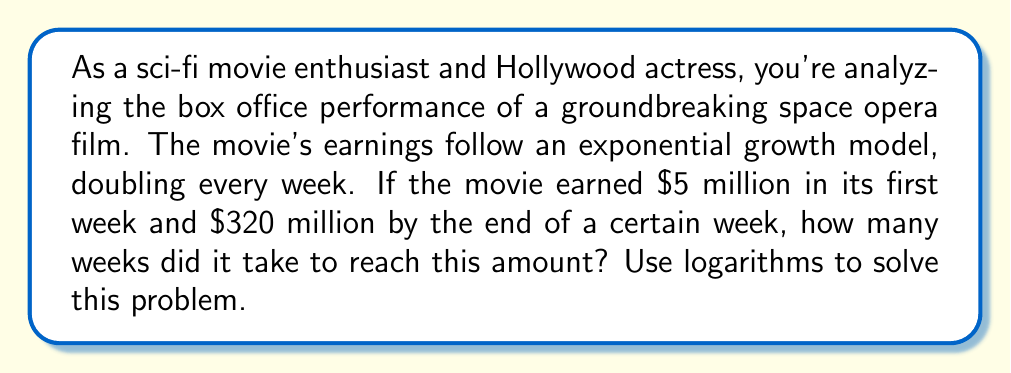Show me your answer to this math problem. Let's approach this step-by-step using logarithms:

1) Let $x$ be the number of weeks and $y$ be the earnings after $x$ weeks.

2) The exponential growth model is:
   $y = 5 \cdot 2^x$
   Where 5 is the initial earnings (in millions) and 2 is the growth factor per week.

3) We want to find $x$ when $y = 320$ million:
   $320 = 5 \cdot 2^x$

4) Divide both sides by 5:
   $64 = 2^x$

5) Now, we can use logarithms to solve for $x$. Let's use log base 2 on both sides:
   $\log_2(64) = \log_2(2^x)$

6) The right side simplifies due to the logarithm property $\log_a(a^x) = x$:
   $\log_2(64) = x$

7) We can calculate $\log_2(64)$:
   $64 = 2^6$, so $\log_2(64) = 6$

Therefore, $x = 6$ weeks.

This can also be solved using natural logarithms:
$\ln(64) = x \ln(2)$
$x = \frac{\ln(64)}{\ln(2)} = \frac{\ln(2^6)}{\ln(2)} = 6$
Answer: It took 6 weeks for the movie to reach $320 million in box office earnings. 